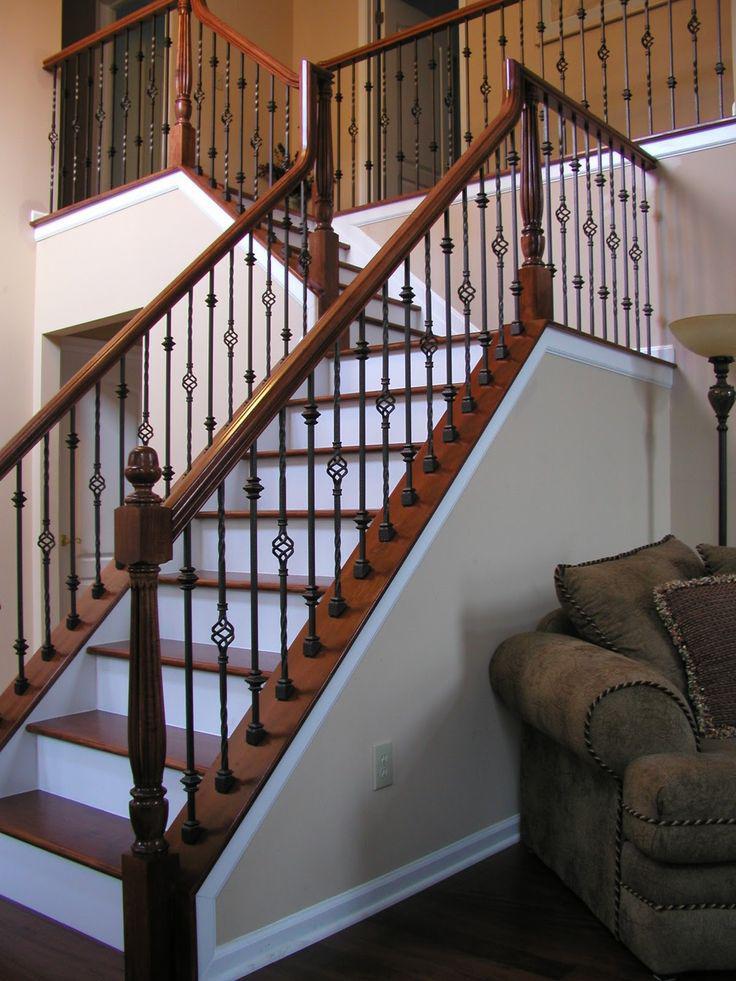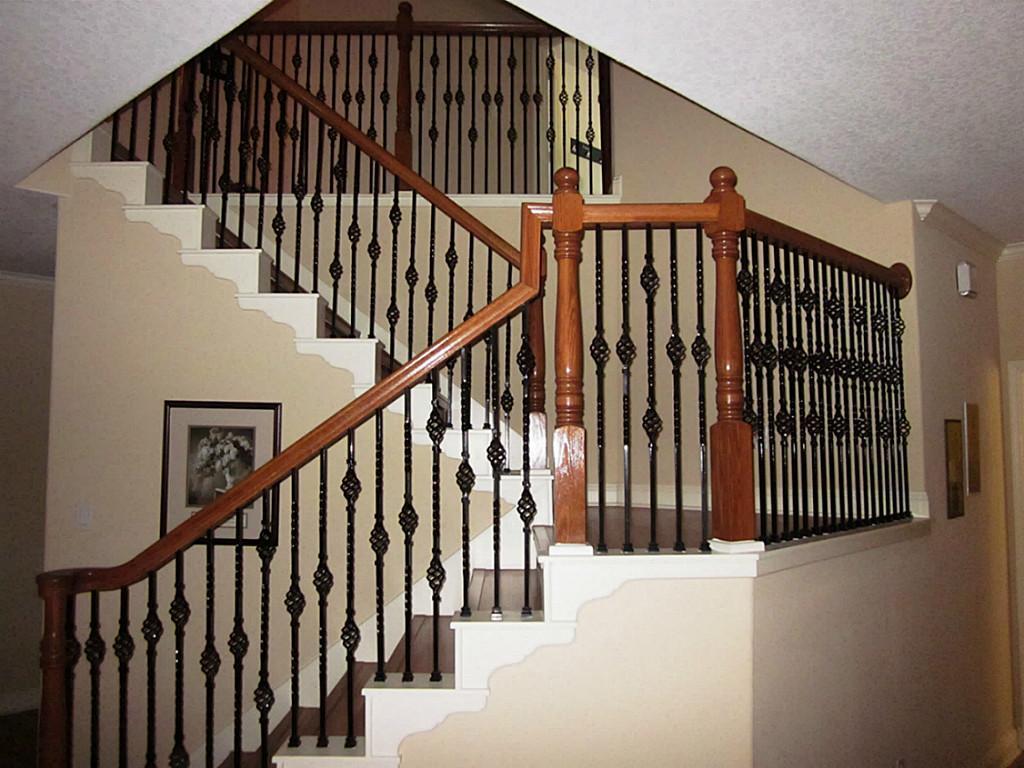The first image is the image on the left, the second image is the image on the right. For the images displayed, is the sentence "Exactly one stairway changes directions." factually correct? Answer yes or no. No. 